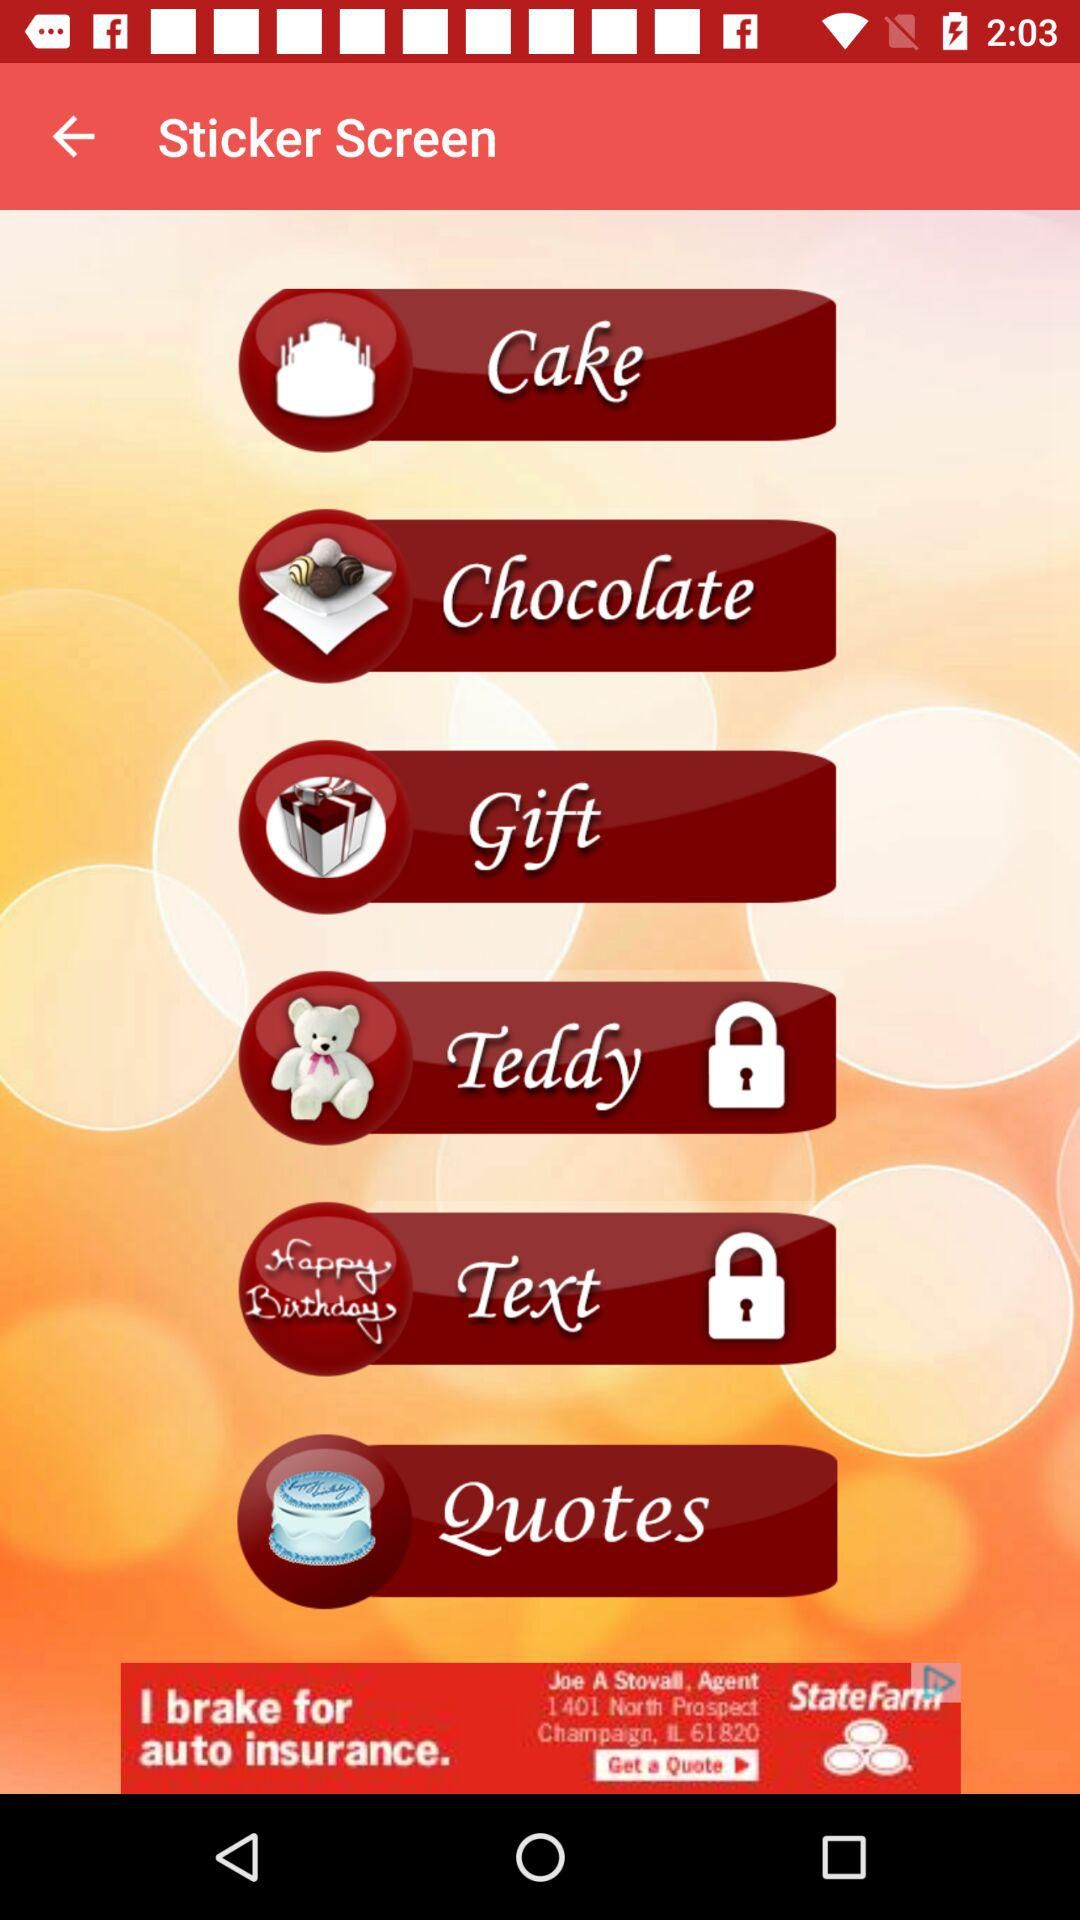Which stickers are locked? The locked stickers are "Teddy" and "Text". 